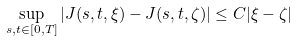<formula> <loc_0><loc_0><loc_500><loc_500>\sup _ { s , t \in [ 0 , T ] } | J ( s , t , \xi ) - J ( s , t , \zeta ) | \leq C | \xi - \zeta |</formula> 